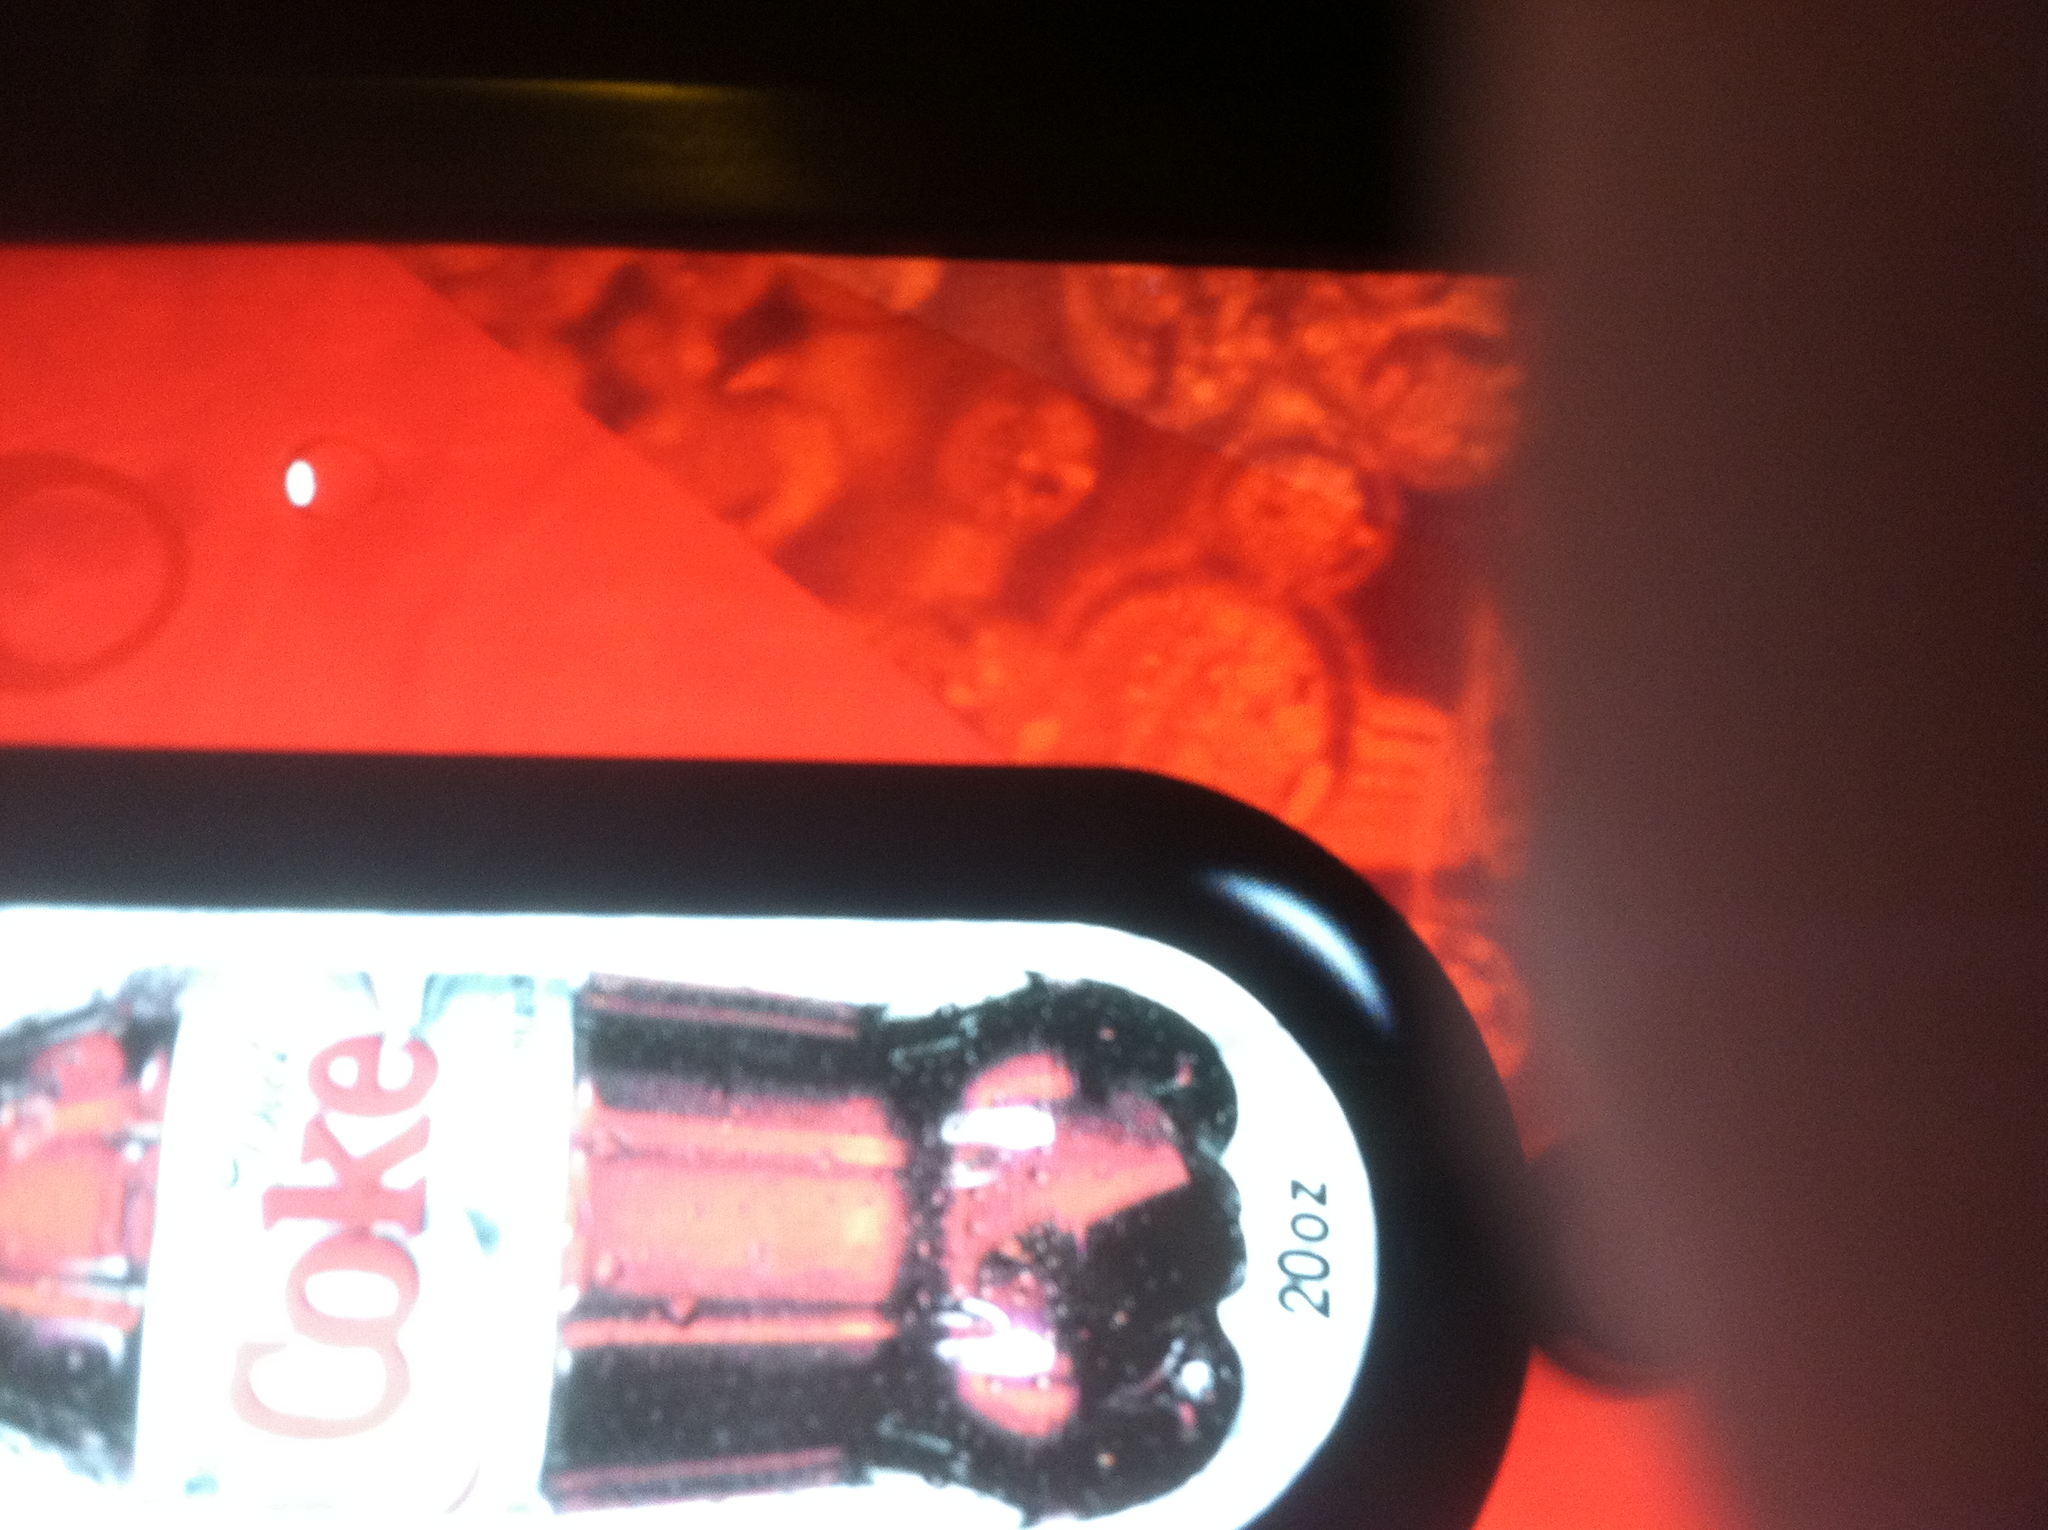Describe the ambiance and setting where this image might have been taken. The image appears to be taken in a setting with low lighting, likely in a vending area or a machine that dispenses soft drinks. The red background and overall lighting suggest a cozy but modern environment, possibly in a cinema, shopping mall, or a casual eatery where consumers can quickly grab a refreshing Diet Coke. What could the red patterns in the background represent? The red patterns in the background might symbolize the iconic bubbly and effervescent nature of Coca-Cola products. The abstract design could be part of a branding strategy to evoke feelings of joy, excitement, and refreshment. 